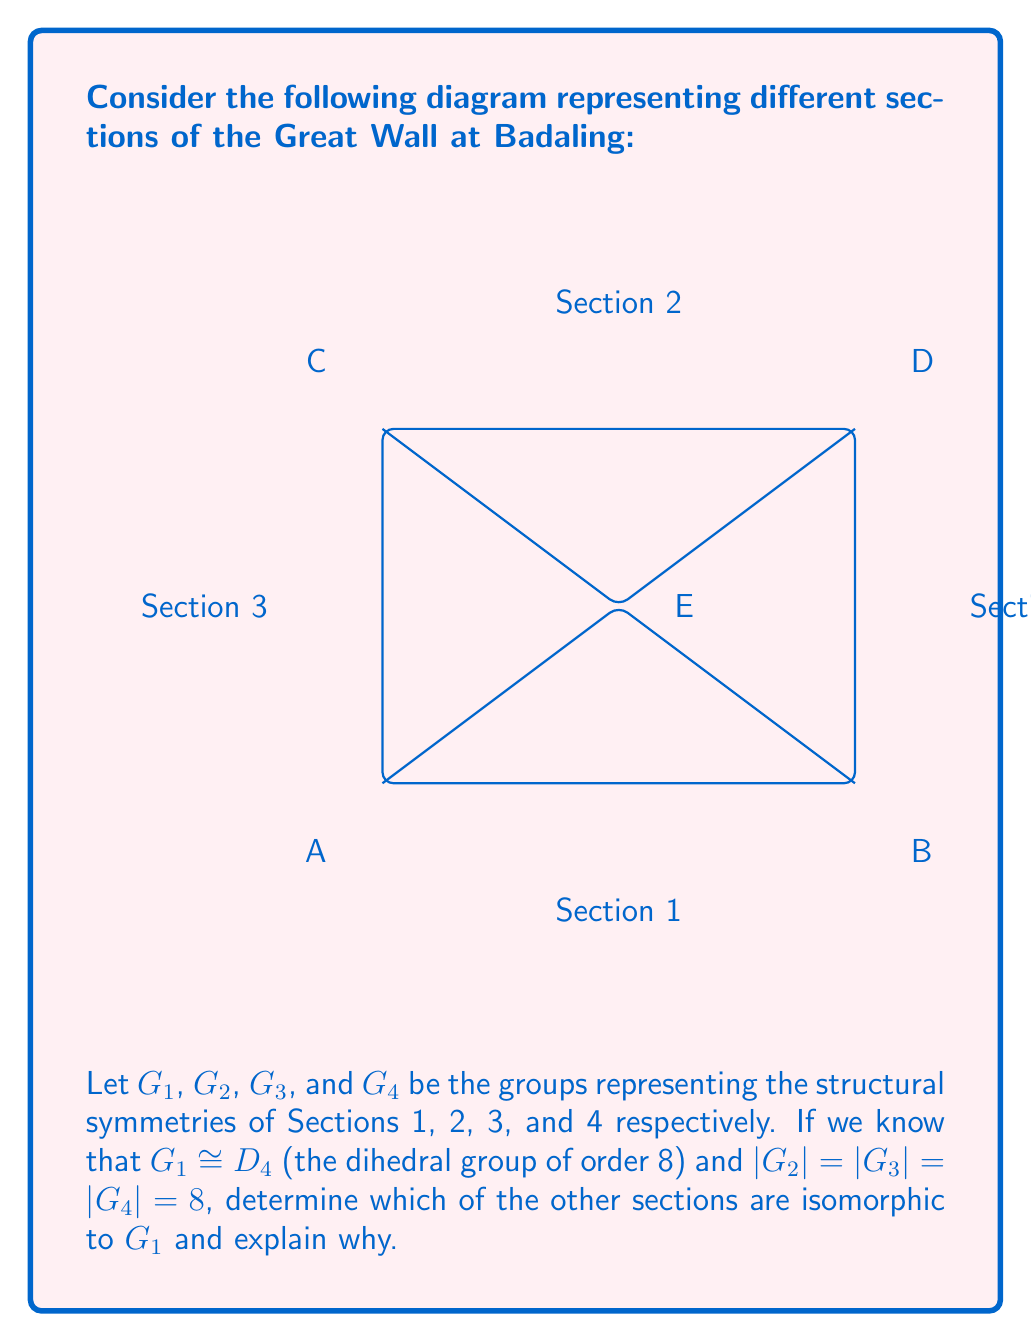Can you answer this question? To solve this problem, we need to analyze the symmetries of each section and compare them to the symmetries of $D_4$. Let's approach this step-by-step:

1) $D_4$ has 8 elements: 4 rotations (0°, 90°, 180°, 270°) and 4 reflections (2 diagonal, 1 horizontal, 1 vertical).

2) Section 1 (bottom): We're told this is isomorphic to $D_4$, which makes sense as it has all the symmetries of a rectangle.

3) Section 2 (top): This section also appears to be a rectangle, just like Section 1. It would have the same 8 symmetries as $D_4$:
   - 4 rotations: 0°, 90°, 180°, 270°
   - 4 reflections: horizontal, vertical, and 2 diagonal

4) Section 3 (left): This is a triangle. The symmetry group of an isosceles triangle is $D_2$, which has only 4 elements:
   - 2 rotations: 0°, 180°
   - 2 reflections: 1 along the height, 1 along the base
   However, we're told $|G_3| = 8$, so this section must have additional symmetries not visible in the 2D representation.

5) Section 4 (right): This section is identical to Section 3, just flipped. It would have the same symmetry group as Section 3.

Therefore, we can conclude that Section 2 is isomorphic to $G_1$ (and thus to $D_4$), while Sections 3 and 4 are not, despite having the same number of elements. The isomorphism between $G_1$ and $G_2$ can be established by mapping each symmetry operation of Section 1 to the corresponding operation of Section 2.
Answer: Only Section 2 is isomorphic to $G_1$ ($D_4$). 